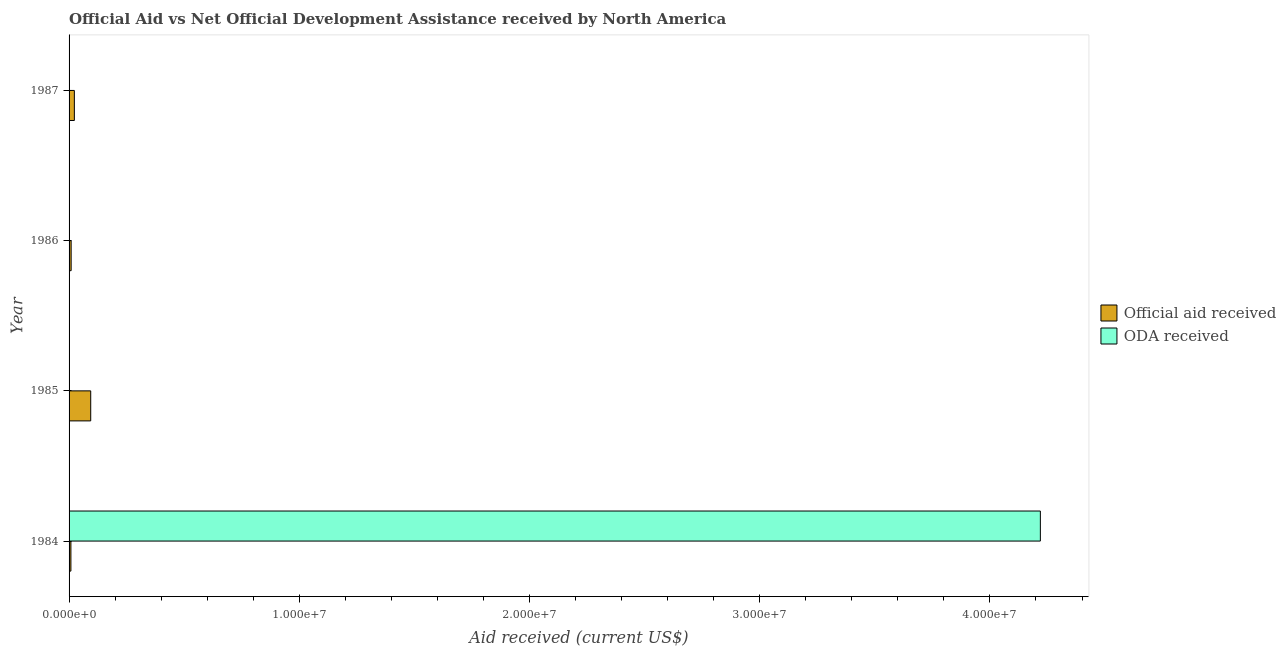Are the number of bars on each tick of the Y-axis equal?
Offer a terse response. No. How many bars are there on the 3rd tick from the bottom?
Provide a short and direct response. 1. What is the official aid received in 1987?
Make the answer very short. 2.30e+05. Across all years, what is the maximum oda received?
Offer a terse response. 4.22e+07. Across all years, what is the minimum oda received?
Ensure brevity in your answer.  0. In which year was the official aid received maximum?
Your response must be concise. 1985. What is the total oda received in the graph?
Ensure brevity in your answer.  4.22e+07. What is the difference between the official aid received in 1984 and that in 1986?
Provide a succinct answer. -10000. What is the difference between the oda received in 1984 and the official aid received in 1987?
Keep it short and to the point. 4.20e+07. What is the average official aid received per year?
Ensure brevity in your answer.  3.35e+05. In the year 1984, what is the difference between the oda received and official aid received?
Offer a terse response. 4.21e+07. In how many years, is the oda received greater than 28000000 US$?
Provide a succinct answer. 1. What is the ratio of the official aid received in 1985 to that in 1986?
Your response must be concise. 10.44. What is the difference between the highest and the second highest official aid received?
Your answer should be compact. 7.10e+05. What is the difference between the highest and the lowest official aid received?
Provide a short and direct response. 8.60e+05. In how many years, is the official aid received greater than the average official aid received taken over all years?
Make the answer very short. 1. Is the sum of the official aid received in 1985 and 1986 greater than the maximum oda received across all years?
Your answer should be compact. No. Does the graph contain any zero values?
Make the answer very short. Yes. Where does the legend appear in the graph?
Give a very brief answer. Center right. How many legend labels are there?
Make the answer very short. 2. How are the legend labels stacked?
Offer a terse response. Vertical. What is the title of the graph?
Provide a succinct answer. Official Aid vs Net Official Development Assistance received by North America . What is the label or title of the X-axis?
Provide a succinct answer. Aid received (current US$). What is the Aid received (current US$) in ODA received in 1984?
Provide a short and direct response. 4.22e+07. What is the Aid received (current US$) in Official aid received in 1985?
Keep it short and to the point. 9.40e+05. What is the Aid received (current US$) in ODA received in 1985?
Keep it short and to the point. 0. Across all years, what is the maximum Aid received (current US$) of Official aid received?
Give a very brief answer. 9.40e+05. Across all years, what is the maximum Aid received (current US$) of ODA received?
Offer a very short reply. 4.22e+07. Across all years, what is the minimum Aid received (current US$) in ODA received?
Offer a terse response. 0. What is the total Aid received (current US$) in Official aid received in the graph?
Your answer should be compact. 1.34e+06. What is the total Aid received (current US$) of ODA received in the graph?
Make the answer very short. 4.22e+07. What is the difference between the Aid received (current US$) of Official aid received in 1984 and that in 1985?
Give a very brief answer. -8.60e+05. What is the difference between the Aid received (current US$) of Official aid received in 1984 and that in 1987?
Provide a succinct answer. -1.50e+05. What is the difference between the Aid received (current US$) of Official aid received in 1985 and that in 1986?
Provide a succinct answer. 8.50e+05. What is the difference between the Aid received (current US$) in Official aid received in 1985 and that in 1987?
Keep it short and to the point. 7.10e+05. What is the difference between the Aid received (current US$) in Official aid received in 1986 and that in 1987?
Keep it short and to the point. -1.40e+05. What is the average Aid received (current US$) of Official aid received per year?
Make the answer very short. 3.35e+05. What is the average Aid received (current US$) of ODA received per year?
Offer a very short reply. 1.05e+07. In the year 1984, what is the difference between the Aid received (current US$) in Official aid received and Aid received (current US$) in ODA received?
Offer a terse response. -4.21e+07. What is the ratio of the Aid received (current US$) in Official aid received in 1984 to that in 1985?
Give a very brief answer. 0.09. What is the ratio of the Aid received (current US$) of Official aid received in 1984 to that in 1987?
Your answer should be very brief. 0.35. What is the ratio of the Aid received (current US$) of Official aid received in 1985 to that in 1986?
Offer a terse response. 10.44. What is the ratio of the Aid received (current US$) in Official aid received in 1985 to that in 1987?
Ensure brevity in your answer.  4.09. What is the ratio of the Aid received (current US$) of Official aid received in 1986 to that in 1987?
Provide a succinct answer. 0.39. What is the difference between the highest and the second highest Aid received (current US$) of Official aid received?
Provide a short and direct response. 7.10e+05. What is the difference between the highest and the lowest Aid received (current US$) in Official aid received?
Your response must be concise. 8.60e+05. What is the difference between the highest and the lowest Aid received (current US$) of ODA received?
Offer a terse response. 4.22e+07. 